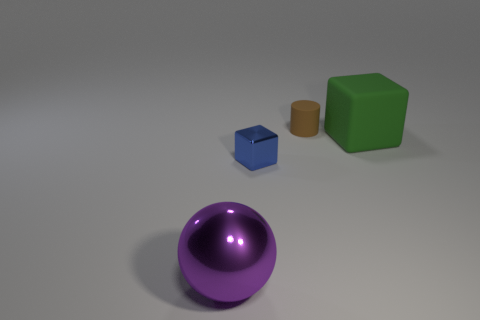Add 4 large rubber cylinders. How many objects exist? 8 Subtract all green cubes. How many cubes are left? 1 Subtract all cylinders. How many objects are left? 3 Subtract 1 cylinders. How many cylinders are left? 0 Add 1 rubber cubes. How many rubber cubes exist? 2 Subtract 0 red blocks. How many objects are left? 4 Subtract all green cubes. Subtract all brown cylinders. How many cubes are left? 1 Subtract all red cubes. How many green balls are left? 0 Subtract all tiny blue metallic blocks. Subtract all large purple objects. How many objects are left? 2 Add 3 tiny metallic blocks. How many tiny metallic blocks are left? 4 